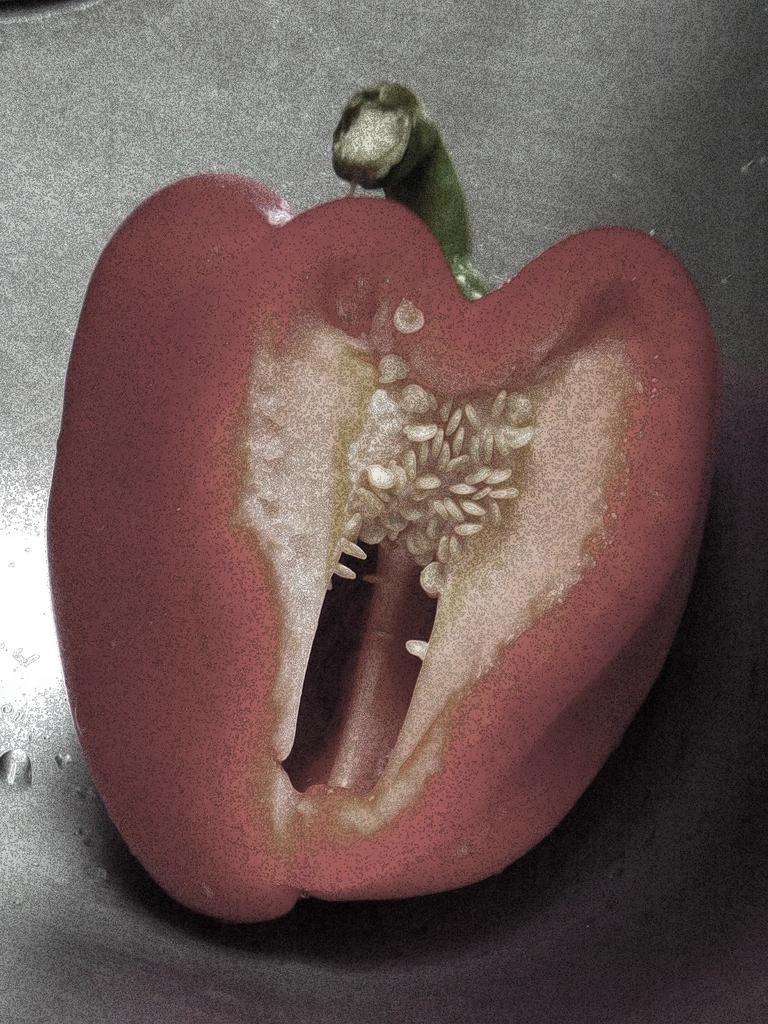What is the main subject of the image? There is a capsicum in the center of the image. Can you describe the unspecified object in the background? Unfortunately, the facts provided do not give any details about the object in the background, so we cannot describe it. How many bulbs are illuminating the capsicum in the image? There is no mention of any bulbs in the image, so we cannot determine how many are present or if they are illuminating the capsicum. Are there any fangs visible on the capsicum in the image? The capsicum is a vegetable and does not have fangs. 